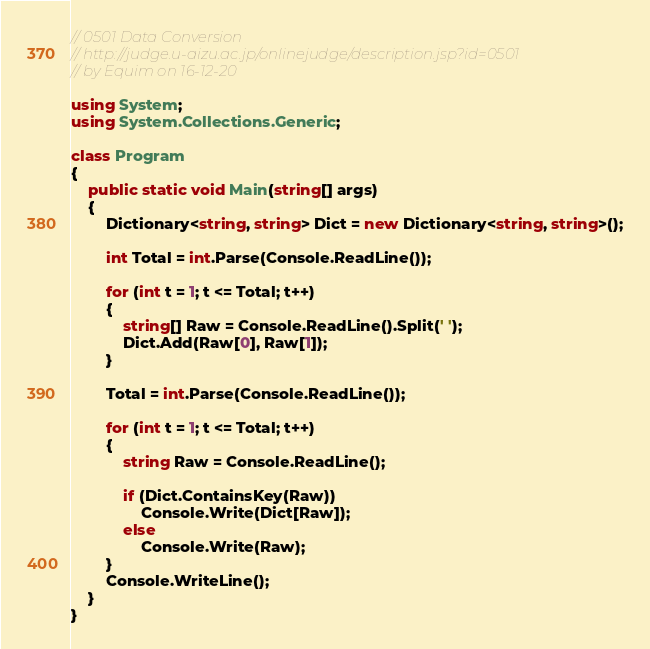Convert code to text. <code><loc_0><loc_0><loc_500><loc_500><_C#_>// 0501 Data Conversion
// http://judge.u-aizu.ac.jp/onlinejudge/description.jsp?id=0501
// by Equim on 16-12-20

using System;
using System.Collections.Generic;

class Program
{
    public static void Main(string[] args)
    {
        Dictionary<string, string> Dict = new Dictionary<string, string>();

        int Total = int.Parse(Console.ReadLine());

        for (int t = 1; t <= Total; t++)
        {
            string[] Raw = Console.ReadLine().Split(' ');
            Dict.Add(Raw[0], Raw[1]);
        }

        Total = int.Parse(Console.ReadLine());

        for (int t = 1; t <= Total; t++)
        {
            string Raw = Console.ReadLine();

            if (Dict.ContainsKey(Raw))
                Console.Write(Dict[Raw]);
            else
                Console.Write(Raw);
        }
        Console.WriteLine();
    }
}</code> 